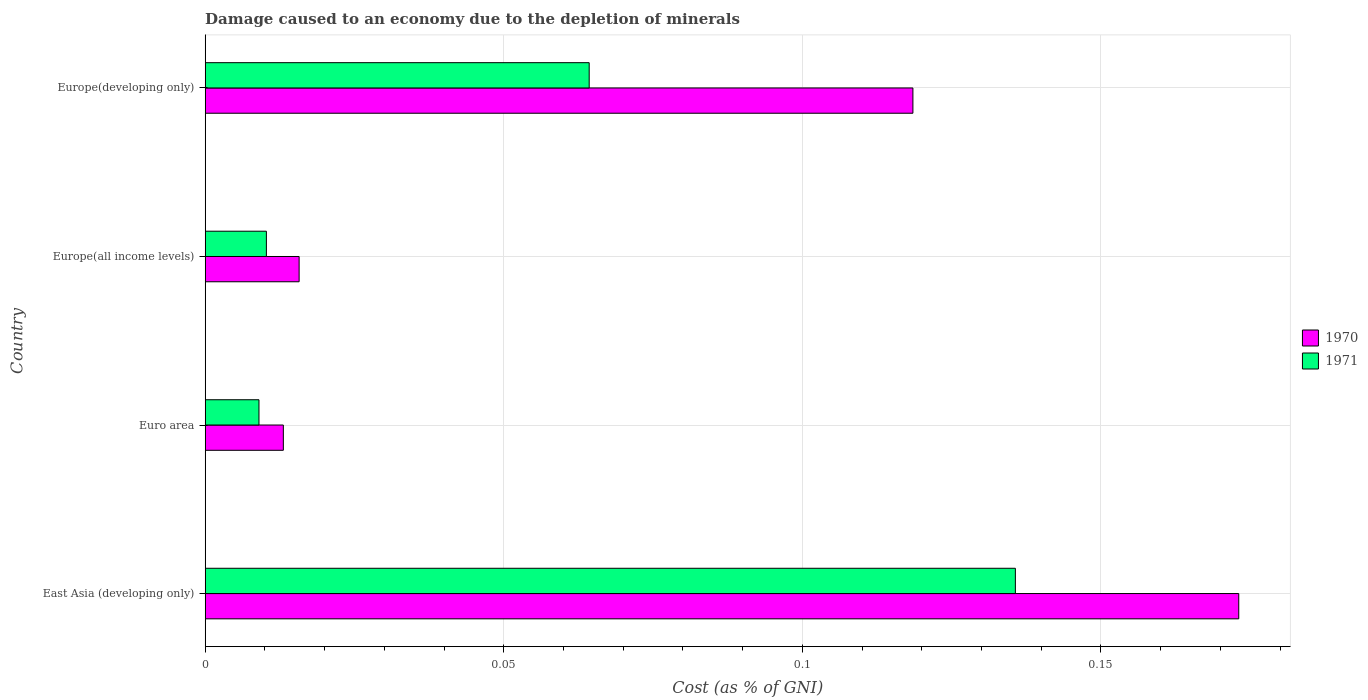How many different coloured bars are there?
Your answer should be compact. 2. Are the number of bars per tick equal to the number of legend labels?
Provide a succinct answer. Yes. Are the number of bars on each tick of the Y-axis equal?
Keep it short and to the point. Yes. What is the label of the 2nd group of bars from the top?
Offer a very short reply. Europe(all income levels). What is the cost of damage caused due to the depletion of minerals in 1971 in Europe(all income levels)?
Your response must be concise. 0.01. Across all countries, what is the maximum cost of damage caused due to the depletion of minerals in 1971?
Make the answer very short. 0.14. Across all countries, what is the minimum cost of damage caused due to the depletion of minerals in 1970?
Keep it short and to the point. 0.01. In which country was the cost of damage caused due to the depletion of minerals in 1970 maximum?
Offer a terse response. East Asia (developing only). What is the total cost of damage caused due to the depletion of minerals in 1971 in the graph?
Your answer should be very brief. 0.22. What is the difference between the cost of damage caused due to the depletion of minerals in 1970 in Euro area and that in Europe(all income levels)?
Your answer should be very brief. -0. What is the difference between the cost of damage caused due to the depletion of minerals in 1970 in East Asia (developing only) and the cost of damage caused due to the depletion of minerals in 1971 in Euro area?
Provide a succinct answer. 0.16. What is the average cost of damage caused due to the depletion of minerals in 1970 per country?
Your response must be concise. 0.08. What is the difference between the cost of damage caused due to the depletion of minerals in 1971 and cost of damage caused due to the depletion of minerals in 1970 in East Asia (developing only)?
Provide a succinct answer. -0.04. In how many countries, is the cost of damage caused due to the depletion of minerals in 1971 greater than 0.04 %?
Your answer should be very brief. 2. What is the ratio of the cost of damage caused due to the depletion of minerals in 1970 in Euro area to that in Europe(developing only)?
Ensure brevity in your answer.  0.11. What is the difference between the highest and the second highest cost of damage caused due to the depletion of minerals in 1970?
Keep it short and to the point. 0.05. What is the difference between the highest and the lowest cost of damage caused due to the depletion of minerals in 1971?
Provide a succinct answer. 0.13. In how many countries, is the cost of damage caused due to the depletion of minerals in 1971 greater than the average cost of damage caused due to the depletion of minerals in 1971 taken over all countries?
Offer a very short reply. 2. What does the 2nd bar from the top in Europe(developing only) represents?
Your response must be concise. 1970. How many bars are there?
Make the answer very short. 8. Are all the bars in the graph horizontal?
Your response must be concise. Yes. What is the difference between two consecutive major ticks on the X-axis?
Ensure brevity in your answer.  0.05. Does the graph contain any zero values?
Offer a very short reply. No. Does the graph contain grids?
Make the answer very short. Yes. Where does the legend appear in the graph?
Ensure brevity in your answer.  Center right. How many legend labels are there?
Ensure brevity in your answer.  2. What is the title of the graph?
Your answer should be compact. Damage caused to an economy due to the depletion of minerals. What is the label or title of the X-axis?
Keep it short and to the point. Cost (as % of GNI). What is the label or title of the Y-axis?
Make the answer very short. Country. What is the Cost (as % of GNI) in 1970 in East Asia (developing only)?
Keep it short and to the point. 0.17. What is the Cost (as % of GNI) in 1971 in East Asia (developing only)?
Give a very brief answer. 0.14. What is the Cost (as % of GNI) in 1970 in Euro area?
Your response must be concise. 0.01. What is the Cost (as % of GNI) in 1971 in Euro area?
Your response must be concise. 0.01. What is the Cost (as % of GNI) in 1970 in Europe(all income levels)?
Ensure brevity in your answer.  0.02. What is the Cost (as % of GNI) of 1971 in Europe(all income levels)?
Provide a short and direct response. 0.01. What is the Cost (as % of GNI) in 1970 in Europe(developing only)?
Your answer should be compact. 0.12. What is the Cost (as % of GNI) of 1971 in Europe(developing only)?
Your answer should be compact. 0.06. Across all countries, what is the maximum Cost (as % of GNI) of 1970?
Provide a short and direct response. 0.17. Across all countries, what is the maximum Cost (as % of GNI) of 1971?
Keep it short and to the point. 0.14. Across all countries, what is the minimum Cost (as % of GNI) of 1970?
Offer a terse response. 0.01. Across all countries, what is the minimum Cost (as % of GNI) of 1971?
Offer a very short reply. 0.01. What is the total Cost (as % of GNI) of 1970 in the graph?
Your response must be concise. 0.32. What is the total Cost (as % of GNI) in 1971 in the graph?
Keep it short and to the point. 0.22. What is the difference between the Cost (as % of GNI) in 1970 in East Asia (developing only) and that in Euro area?
Your response must be concise. 0.16. What is the difference between the Cost (as % of GNI) of 1971 in East Asia (developing only) and that in Euro area?
Provide a succinct answer. 0.13. What is the difference between the Cost (as % of GNI) of 1970 in East Asia (developing only) and that in Europe(all income levels)?
Ensure brevity in your answer.  0.16. What is the difference between the Cost (as % of GNI) in 1971 in East Asia (developing only) and that in Europe(all income levels)?
Offer a very short reply. 0.13. What is the difference between the Cost (as % of GNI) of 1970 in East Asia (developing only) and that in Europe(developing only)?
Your answer should be very brief. 0.05. What is the difference between the Cost (as % of GNI) of 1971 in East Asia (developing only) and that in Europe(developing only)?
Ensure brevity in your answer.  0.07. What is the difference between the Cost (as % of GNI) in 1970 in Euro area and that in Europe(all income levels)?
Your answer should be very brief. -0. What is the difference between the Cost (as % of GNI) in 1971 in Euro area and that in Europe(all income levels)?
Give a very brief answer. -0. What is the difference between the Cost (as % of GNI) in 1970 in Euro area and that in Europe(developing only)?
Provide a succinct answer. -0.11. What is the difference between the Cost (as % of GNI) of 1971 in Euro area and that in Europe(developing only)?
Offer a very short reply. -0.06. What is the difference between the Cost (as % of GNI) in 1970 in Europe(all income levels) and that in Europe(developing only)?
Offer a terse response. -0.1. What is the difference between the Cost (as % of GNI) of 1971 in Europe(all income levels) and that in Europe(developing only)?
Your response must be concise. -0.05. What is the difference between the Cost (as % of GNI) of 1970 in East Asia (developing only) and the Cost (as % of GNI) of 1971 in Euro area?
Your answer should be very brief. 0.16. What is the difference between the Cost (as % of GNI) of 1970 in East Asia (developing only) and the Cost (as % of GNI) of 1971 in Europe(all income levels)?
Provide a succinct answer. 0.16. What is the difference between the Cost (as % of GNI) of 1970 in East Asia (developing only) and the Cost (as % of GNI) of 1971 in Europe(developing only)?
Your answer should be very brief. 0.11. What is the difference between the Cost (as % of GNI) of 1970 in Euro area and the Cost (as % of GNI) of 1971 in Europe(all income levels)?
Give a very brief answer. 0. What is the difference between the Cost (as % of GNI) of 1970 in Euro area and the Cost (as % of GNI) of 1971 in Europe(developing only)?
Provide a short and direct response. -0.05. What is the difference between the Cost (as % of GNI) in 1970 in Europe(all income levels) and the Cost (as % of GNI) in 1971 in Europe(developing only)?
Give a very brief answer. -0.05. What is the average Cost (as % of GNI) in 1970 per country?
Your answer should be very brief. 0.08. What is the average Cost (as % of GNI) of 1971 per country?
Your answer should be compact. 0.05. What is the difference between the Cost (as % of GNI) in 1970 and Cost (as % of GNI) in 1971 in East Asia (developing only)?
Your answer should be very brief. 0.04. What is the difference between the Cost (as % of GNI) in 1970 and Cost (as % of GNI) in 1971 in Euro area?
Ensure brevity in your answer.  0. What is the difference between the Cost (as % of GNI) of 1970 and Cost (as % of GNI) of 1971 in Europe(all income levels)?
Your answer should be very brief. 0.01. What is the difference between the Cost (as % of GNI) in 1970 and Cost (as % of GNI) in 1971 in Europe(developing only)?
Ensure brevity in your answer.  0.05. What is the ratio of the Cost (as % of GNI) in 1970 in East Asia (developing only) to that in Euro area?
Offer a very short reply. 13.22. What is the ratio of the Cost (as % of GNI) in 1971 in East Asia (developing only) to that in Euro area?
Make the answer very short. 15.07. What is the ratio of the Cost (as % of GNI) of 1970 in East Asia (developing only) to that in Europe(all income levels)?
Keep it short and to the point. 11. What is the ratio of the Cost (as % of GNI) in 1971 in East Asia (developing only) to that in Europe(all income levels)?
Offer a terse response. 13.24. What is the ratio of the Cost (as % of GNI) in 1970 in East Asia (developing only) to that in Europe(developing only)?
Make the answer very short. 1.46. What is the ratio of the Cost (as % of GNI) of 1971 in East Asia (developing only) to that in Europe(developing only)?
Provide a short and direct response. 2.11. What is the ratio of the Cost (as % of GNI) of 1970 in Euro area to that in Europe(all income levels)?
Give a very brief answer. 0.83. What is the ratio of the Cost (as % of GNI) in 1971 in Euro area to that in Europe(all income levels)?
Your answer should be compact. 0.88. What is the ratio of the Cost (as % of GNI) of 1970 in Euro area to that in Europe(developing only)?
Provide a succinct answer. 0.11. What is the ratio of the Cost (as % of GNI) of 1971 in Euro area to that in Europe(developing only)?
Your response must be concise. 0.14. What is the ratio of the Cost (as % of GNI) of 1970 in Europe(all income levels) to that in Europe(developing only)?
Keep it short and to the point. 0.13. What is the ratio of the Cost (as % of GNI) in 1971 in Europe(all income levels) to that in Europe(developing only)?
Make the answer very short. 0.16. What is the difference between the highest and the second highest Cost (as % of GNI) in 1970?
Offer a terse response. 0.05. What is the difference between the highest and the second highest Cost (as % of GNI) in 1971?
Your response must be concise. 0.07. What is the difference between the highest and the lowest Cost (as % of GNI) in 1970?
Provide a short and direct response. 0.16. What is the difference between the highest and the lowest Cost (as % of GNI) of 1971?
Keep it short and to the point. 0.13. 